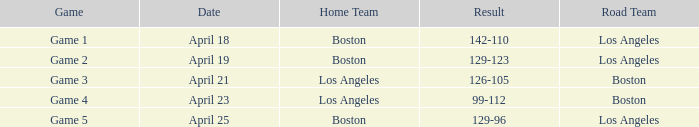WHAT IS THE HOME TEAM ON APRIL 25? Boston. 